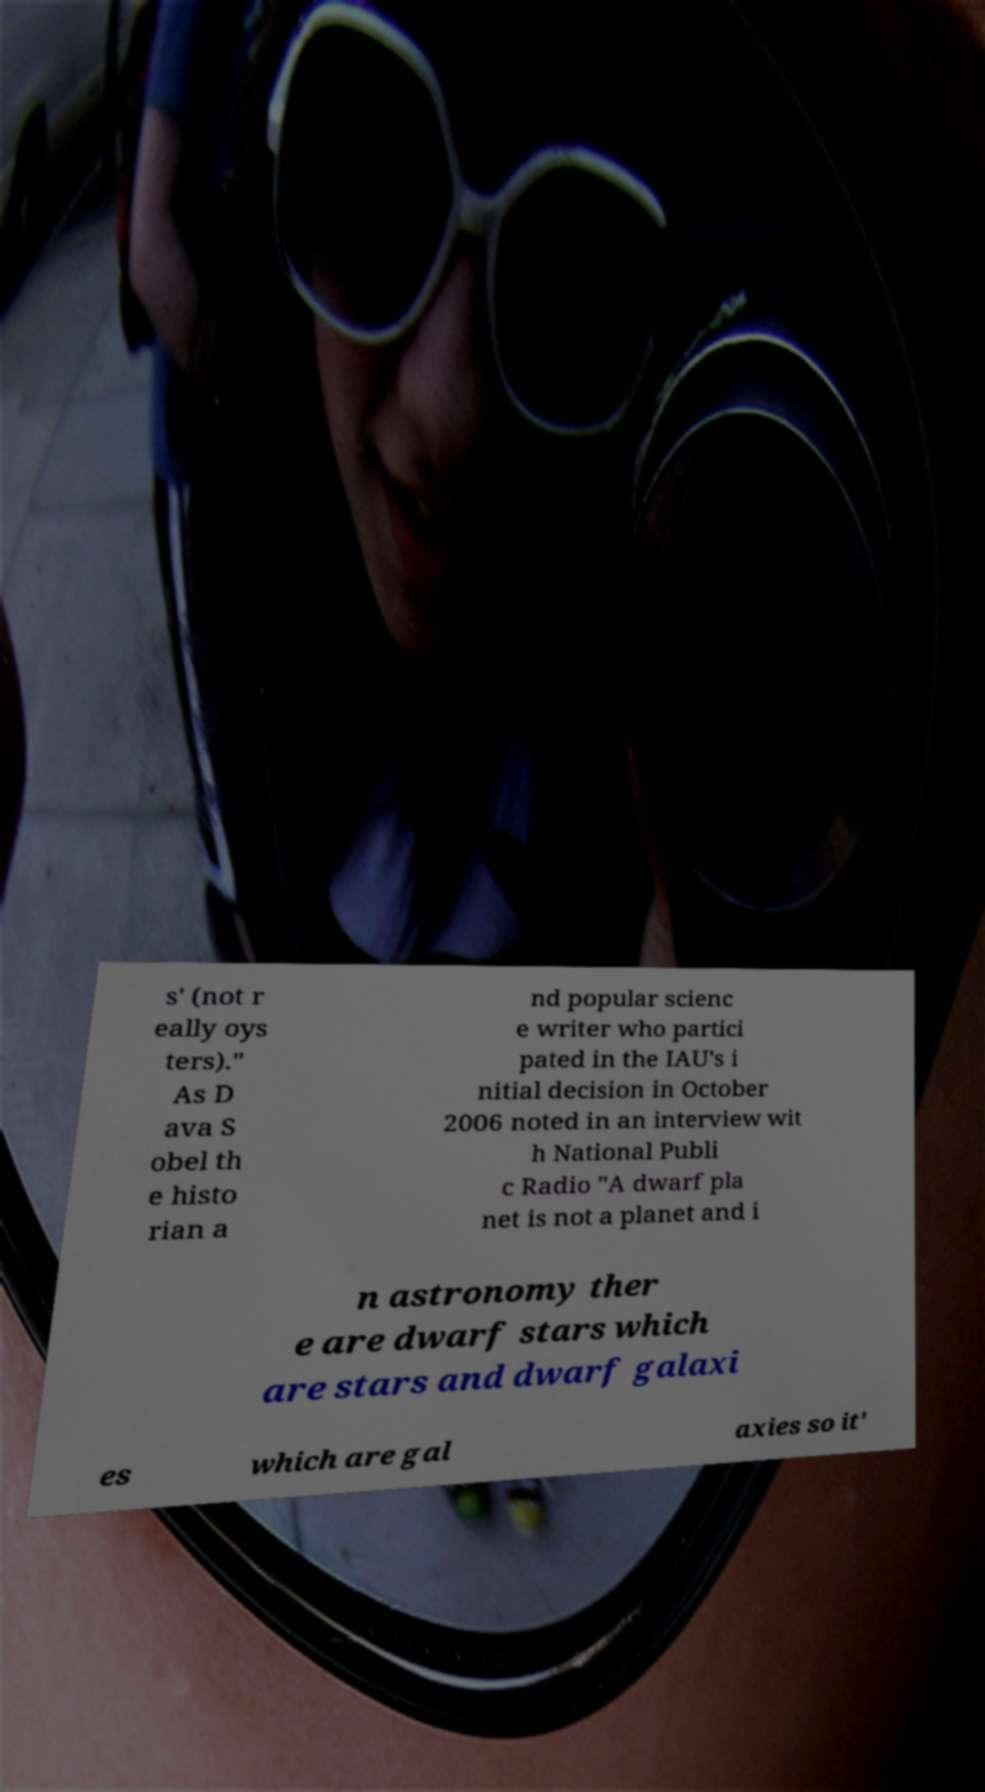Please identify and transcribe the text found in this image. s' (not r eally oys ters)." As D ava S obel th e histo rian a nd popular scienc e writer who partici pated in the IAU's i nitial decision in October 2006 noted in an interview wit h National Publi c Radio "A dwarf pla net is not a planet and i n astronomy ther e are dwarf stars which are stars and dwarf galaxi es which are gal axies so it' 